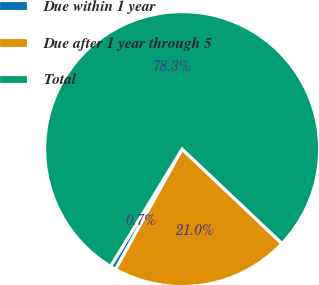Convert chart. <chart><loc_0><loc_0><loc_500><loc_500><pie_chart><fcel>Due within 1 year<fcel>Due after 1 year through 5<fcel>Total<nl><fcel>0.67%<fcel>20.99%<fcel>78.34%<nl></chart> 